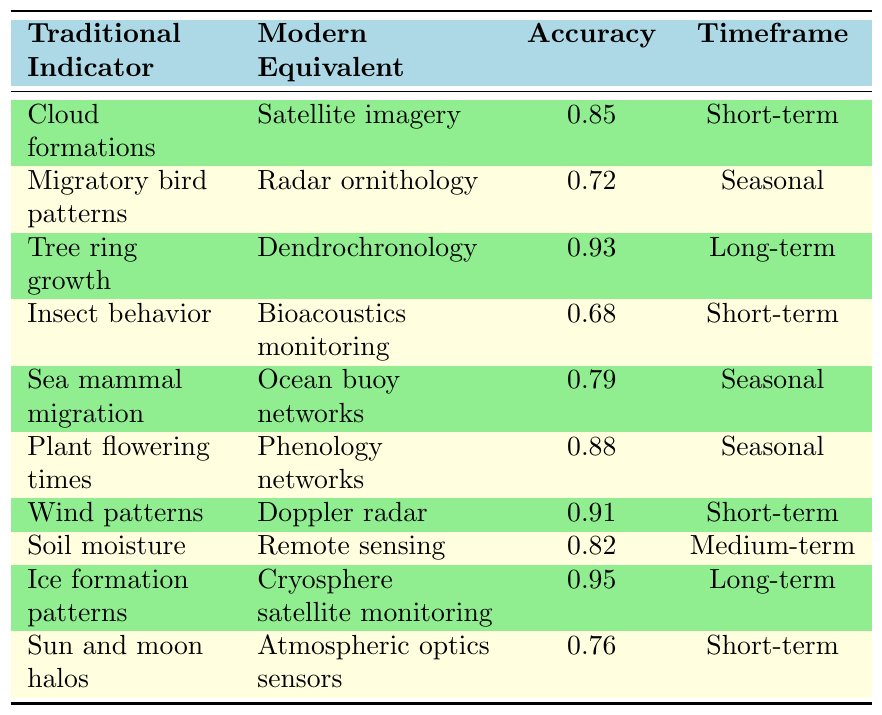What is the modern equivalent for "Cloud formations"? Referring to the table, the traditional indicator "Cloud formations" has "Satellite imagery" as its modern equivalent.
Answer: Satellite imagery Which traditional indicator has the highest accuracy? By reviewing the accuracy values in the table, "Ice formation patterns" has the highest accuracy of 0.95.
Answer: Ice formation patterns Is "Insect behavior" a short-term indicator? The table shows that "Insect behavior" is indeed categorized under the short-term timeframe.
Answer: Yes What is the accuracy of "Plant flowering times"? Looking at the table, the accuracy for "Plant flowering times" is 0.88.
Answer: 0.88 Which indicators have a seasonal timeframe? The table lists "Migratory bird patterns," "Sea mammal migration," and "Plant flowering times" as indicators with a seasonal timeframe.
Answer: Migratory bird patterns, Sea mammal migration, Plant flowering times Which modern equivalent has the lowest accuracy? By comparing the accuracy values, "Bioacoustics monitoring," corresponding to "Insect behavior," has the lowest accuracy at 0.68.
Answer: Bioacoustics monitoring What is the average accuracy of all short-term indicators? The short-term indicators are "Cloud formations" (0.85), "Insect behavior" (0.68), "Wind patterns" (0.91), and "Sun and moon halos" (0.76). The sum is 0.85 + 0.68 + 0.91 + 0.76 = 3.20. There are 4 short-term indicators, so the average accuracy is 3.20 / 4 = 0.80.
Answer: 0.80 Does "Tree ring growth" use "Dendrochronology"? The table indicates that "Tree ring growth" is indeed paired with "Dendrochronology" as its modern equivalent.
Answer: Yes What is the difference in accuracy between "Wind patterns" and "Soil moisture"? The accuracy for "Wind patterns" is 0.91 and for "Soil moisture" it is 0.82. The difference is calculated as 0.91 - 0.82 = 0.09.
Answer: 0.09 Which traditional indicator has a modern equivalent that focuses on marine life? "Sea mammal migration" corresponds to the modern equivalent "Ocean buoy networks," which focuses on marine life.
Answer: Sea mammal migration 